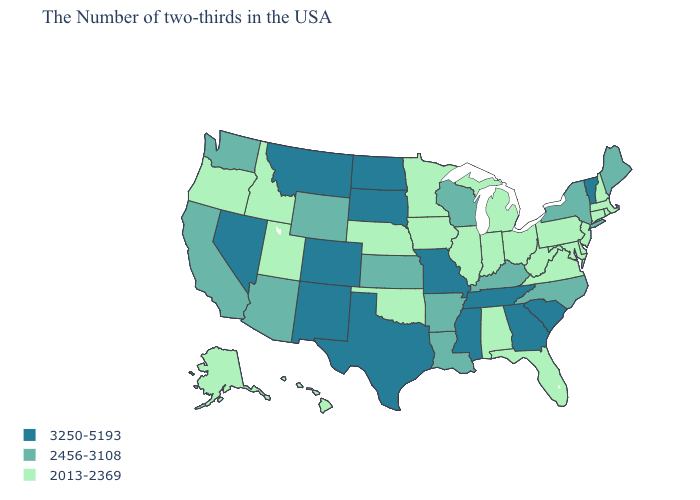How many symbols are there in the legend?
Be succinct. 3. Which states have the highest value in the USA?
Short answer required. Vermont, South Carolina, Georgia, Tennessee, Mississippi, Missouri, Texas, South Dakota, North Dakota, Colorado, New Mexico, Montana, Nevada. Name the states that have a value in the range 2456-3108?
Keep it brief. Maine, New York, North Carolina, Kentucky, Wisconsin, Louisiana, Arkansas, Kansas, Wyoming, Arizona, California, Washington. Name the states that have a value in the range 2013-2369?
Short answer required. Massachusetts, Rhode Island, New Hampshire, Connecticut, New Jersey, Delaware, Maryland, Pennsylvania, Virginia, West Virginia, Ohio, Florida, Michigan, Indiana, Alabama, Illinois, Minnesota, Iowa, Nebraska, Oklahoma, Utah, Idaho, Oregon, Alaska, Hawaii. What is the value of Washington?
Keep it brief. 2456-3108. Among the states that border Delaware , which have the highest value?
Write a very short answer. New Jersey, Maryland, Pennsylvania. Name the states that have a value in the range 2456-3108?
Write a very short answer. Maine, New York, North Carolina, Kentucky, Wisconsin, Louisiana, Arkansas, Kansas, Wyoming, Arizona, California, Washington. Does Utah have a higher value than South Dakota?
Answer briefly. No. What is the value of New Jersey?
Answer briefly. 2013-2369. What is the lowest value in the Northeast?
Concise answer only. 2013-2369. Is the legend a continuous bar?
Keep it brief. No. What is the highest value in states that border Minnesota?
Be succinct. 3250-5193. Among the states that border New Hampshire , which have the lowest value?
Concise answer only. Massachusetts. What is the lowest value in the Northeast?
Concise answer only. 2013-2369. Name the states that have a value in the range 3250-5193?
Give a very brief answer. Vermont, South Carolina, Georgia, Tennessee, Mississippi, Missouri, Texas, South Dakota, North Dakota, Colorado, New Mexico, Montana, Nevada. 